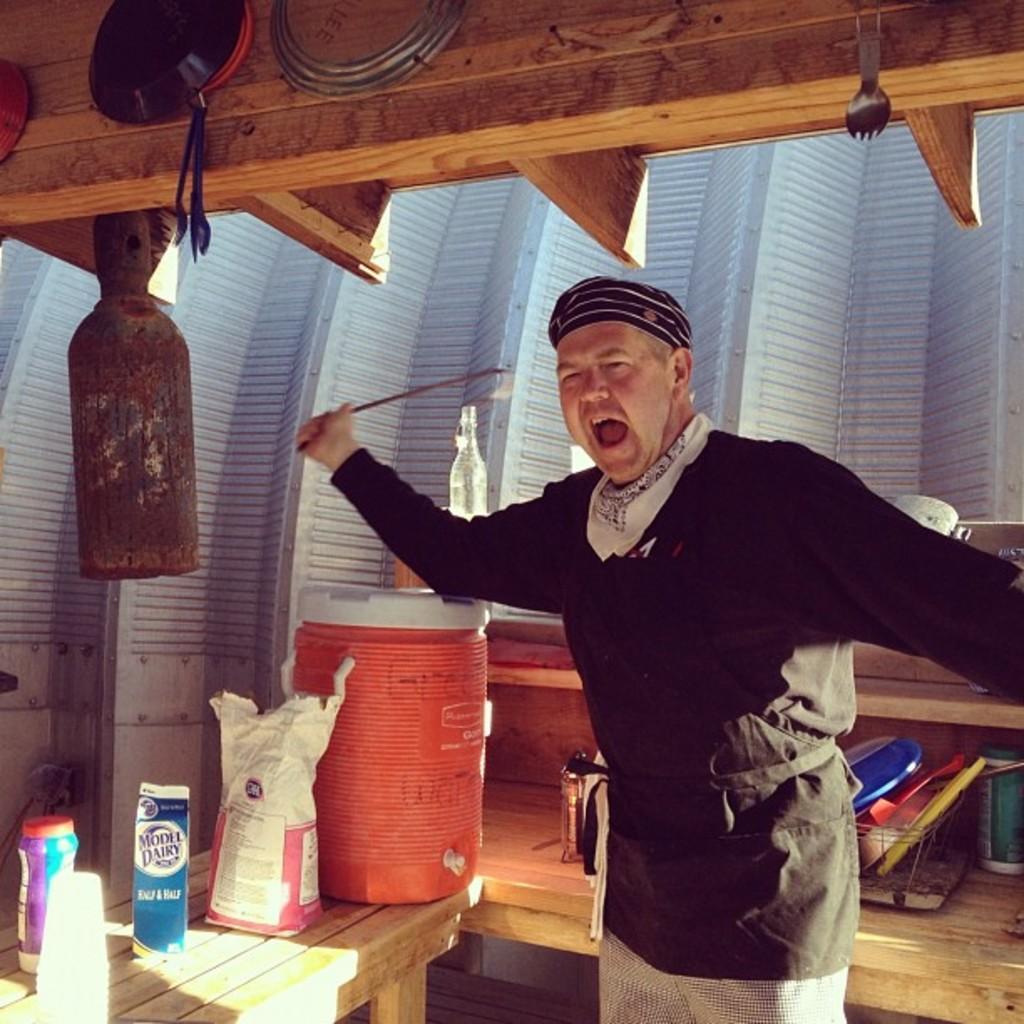Please provide a concise description of this image. Here I can see a man holding an object in the hand, standing and shouting. Beside him there is a table on which a drum, bag, bottles and some other objects are placed. In the background there is a wall. At the top of the image there is a wooden board on which few objects are hanging. 